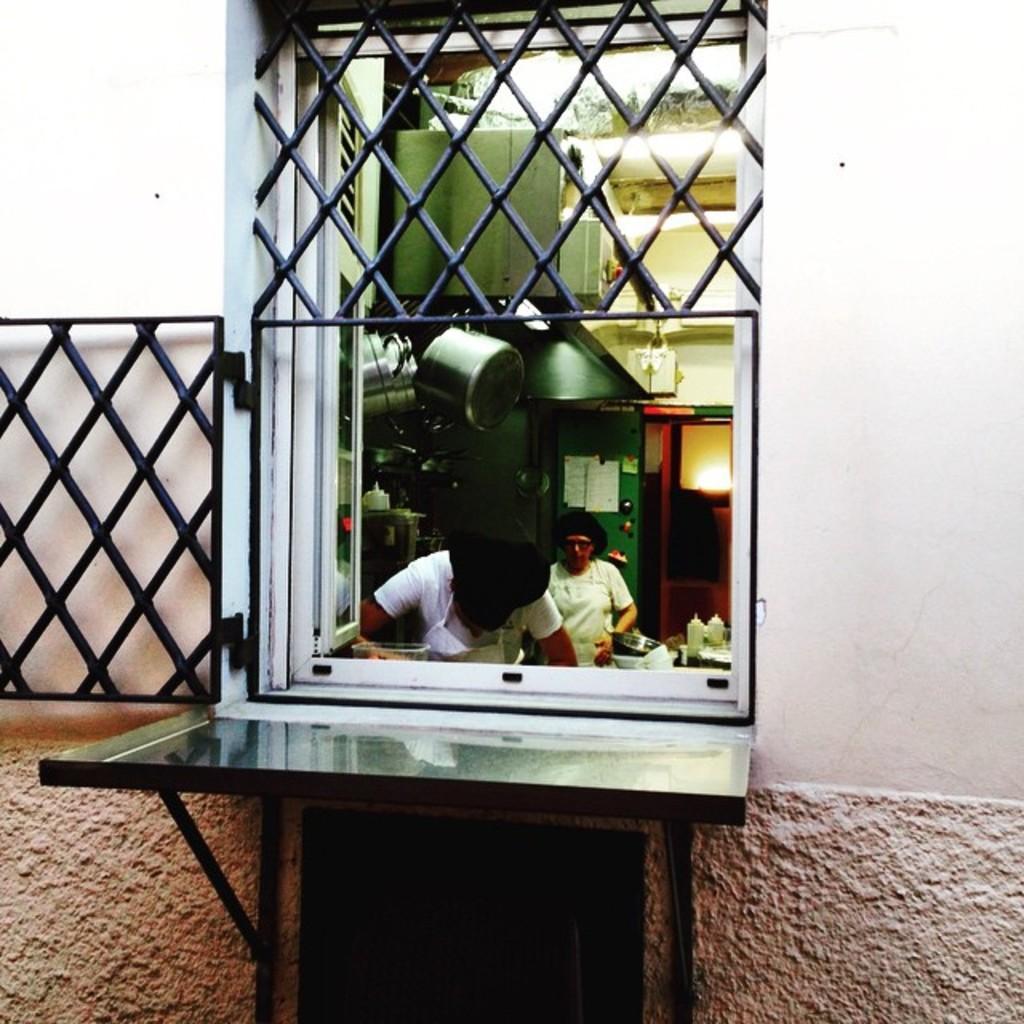In one or two sentences, can you explain what this image depicts? This is the picture of a building. In this image there are two persons standing inside the room. There are utensils and there is a cupboard and light inside the room. In the foreground there is a railing on the window and there is a wall. 